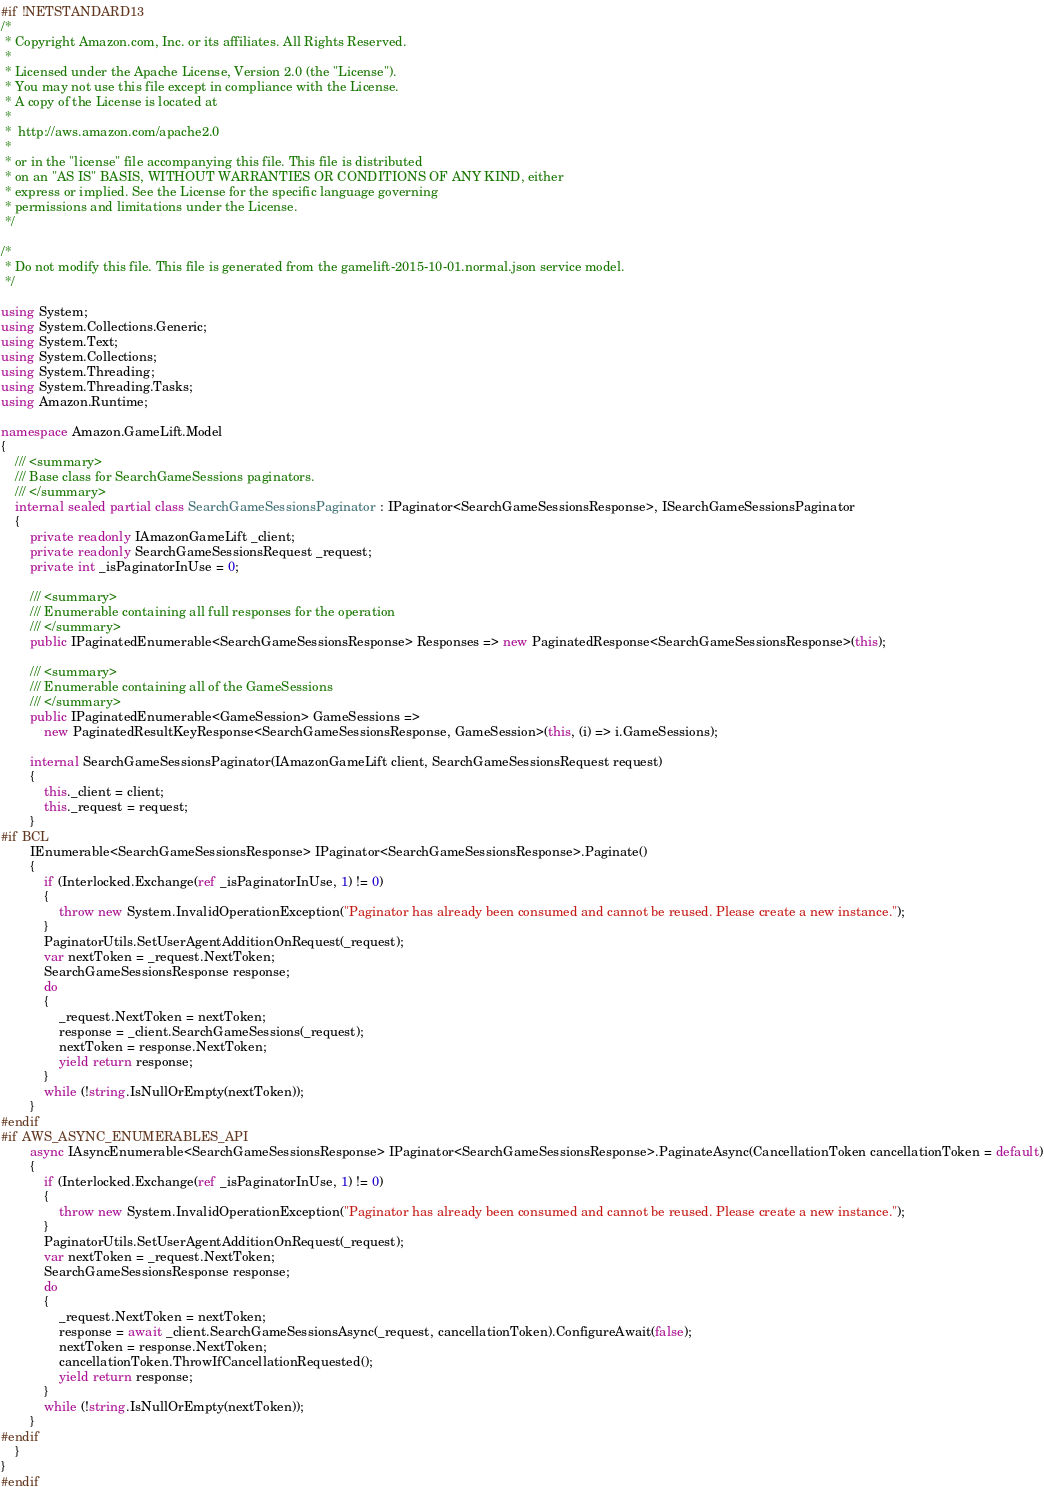Convert code to text. <code><loc_0><loc_0><loc_500><loc_500><_C#_>#if !NETSTANDARD13
/*
 * Copyright Amazon.com, Inc. or its affiliates. All Rights Reserved.
 * 
 * Licensed under the Apache License, Version 2.0 (the "License").
 * You may not use this file except in compliance with the License.
 * A copy of the License is located at
 * 
 *  http://aws.amazon.com/apache2.0
 * 
 * or in the "license" file accompanying this file. This file is distributed
 * on an "AS IS" BASIS, WITHOUT WARRANTIES OR CONDITIONS OF ANY KIND, either
 * express or implied. See the License for the specific language governing
 * permissions and limitations under the License.
 */

/*
 * Do not modify this file. This file is generated from the gamelift-2015-10-01.normal.json service model.
 */

using System;
using System.Collections.Generic;
using System.Text;
using System.Collections;
using System.Threading;
using System.Threading.Tasks;
using Amazon.Runtime;
 
namespace Amazon.GameLift.Model
{
    /// <summary>
    /// Base class for SearchGameSessions paginators.
    /// </summary>
    internal sealed partial class SearchGameSessionsPaginator : IPaginator<SearchGameSessionsResponse>, ISearchGameSessionsPaginator
    {
        private readonly IAmazonGameLift _client;
        private readonly SearchGameSessionsRequest _request;
        private int _isPaginatorInUse = 0;
        
        /// <summary>
        /// Enumerable containing all full responses for the operation
        /// </summary>
        public IPaginatedEnumerable<SearchGameSessionsResponse> Responses => new PaginatedResponse<SearchGameSessionsResponse>(this);

        /// <summary>
        /// Enumerable containing all of the GameSessions
        /// </summary>
        public IPaginatedEnumerable<GameSession> GameSessions => 
            new PaginatedResultKeyResponse<SearchGameSessionsResponse, GameSession>(this, (i) => i.GameSessions);

        internal SearchGameSessionsPaginator(IAmazonGameLift client, SearchGameSessionsRequest request)
        {
            this._client = client;
            this._request = request;
        }
#if BCL
        IEnumerable<SearchGameSessionsResponse> IPaginator<SearchGameSessionsResponse>.Paginate()
        {
            if (Interlocked.Exchange(ref _isPaginatorInUse, 1) != 0)
            {
                throw new System.InvalidOperationException("Paginator has already been consumed and cannot be reused. Please create a new instance.");
            }
            PaginatorUtils.SetUserAgentAdditionOnRequest(_request);
            var nextToken = _request.NextToken;
            SearchGameSessionsResponse response;
            do
            {
                _request.NextToken = nextToken;
                response = _client.SearchGameSessions(_request);
                nextToken = response.NextToken;
                yield return response;
            }
            while (!string.IsNullOrEmpty(nextToken));
        }
#endif
#if AWS_ASYNC_ENUMERABLES_API
        async IAsyncEnumerable<SearchGameSessionsResponse> IPaginator<SearchGameSessionsResponse>.PaginateAsync(CancellationToken cancellationToken = default)
        {
            if (Interlocked.Exchange(ref _isPaginatorInUse, 1) != 0)
            {
                throw new System.InvalidOperationException("Paginator has already been consumed and cannot be reused. Please create a new instance.");
            }
            PaginatorUtils.SetUserAgentAdditionOnRequest(_request);
            var nextToken = _request.NextToken;
            SearchGameSessionsResponse response;
            do
            {
                _request.NextToken = nextToken;
                response = await _client.SearchGameSessionsAsync(_request, cancellationToken).ConfigureAwait(false);
                nextToken = response.NextToken;
                cancellationToken.ThrowIfCancellationRequested();
                yield return response;
            }
            while (!string.IsNullOrEmpty(nextToken));
        }
#endif
    }
}
#endif</code> 